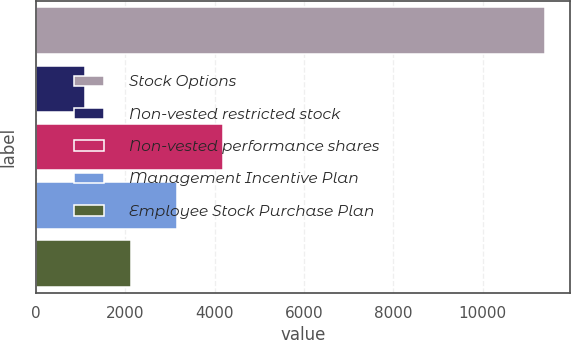<chart> <loc_0><loc_0><loc_500><loc_500><bar_chart><fcel>Stock Options<fcel>Non-vested restricted stock<fcel>Non-vested performance shares<fcel>Management Incentive Plan<fcel>Employee Stock Purchase Plan<nl><fcel>11382<fcel>1111<fcel>4192.3<fcel>3165.2<fcel>2138.1<nl></chart> 